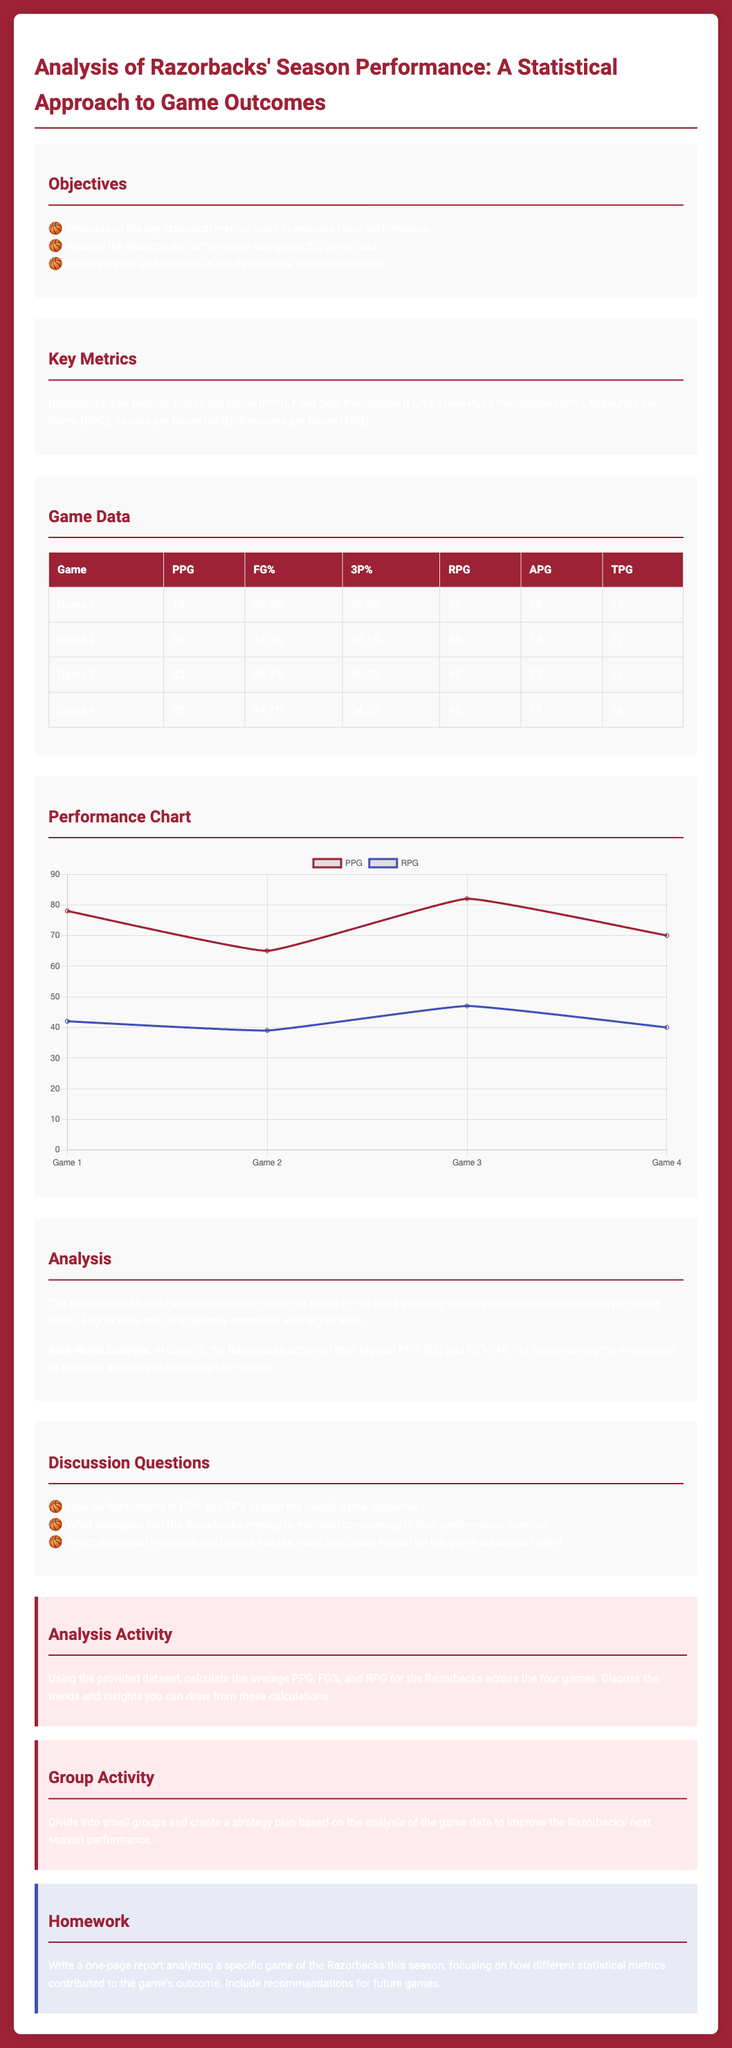What is the title of the lesson plan? The title provides the main focus of the lesson, which is "Analysis of Razorbacks' Season Performance: A Statistical Approach to Game Outcomes."
Answer: Analysis of Razorbacks' Season Performance: A Statistical Approach to Game Outcomes What is the average Points per Game (PPG) from all games? The PPG for the four games is calculated by averaging the PPG values from the game data table.
Answer: 73.75 What is the highest Field Goal Percentage (FG%) in the provided game data? The highest FG% among the game data is found in Game 3, which is 48.7%.
Answer: 48.7% Which statistical metric is considered to be the most significant impact on the game outcomes? This question is aimed at understanding opinions included in the discussion questions section of the lesson plan.
Answer: N/A What was the Points per Game (PPG) for Game 4? The PPG for Game 4 is specifically listed in the game data table.
Answer: 70 Which game had the highest Rebounds per Game (RPG)? The RPG values from the game data table are compared to identify the game with the highest RPG.
Answer: Game 3 What are the Key Metrics assessed in this analysis? The key metrics are explicitly listed in the Key Metrics section of the document, outlining crucial performance indicators.
Answer: Points per Game, Field Goal Percentage, Three-Point Percentage, Rebounds per Game, Assists per Game, Turnovers per Game What is the objective of this lesson plan? The objective section outlines what the lesson aims to achieve regarding Razorbacks' performance analysis.
Answer: Understand the key statistical metrics used to evaluate team performance What type of chart is used in the Performance Chart section? The chart type reflects the visualization method used to depict performance data over the games.
Answer: Line 